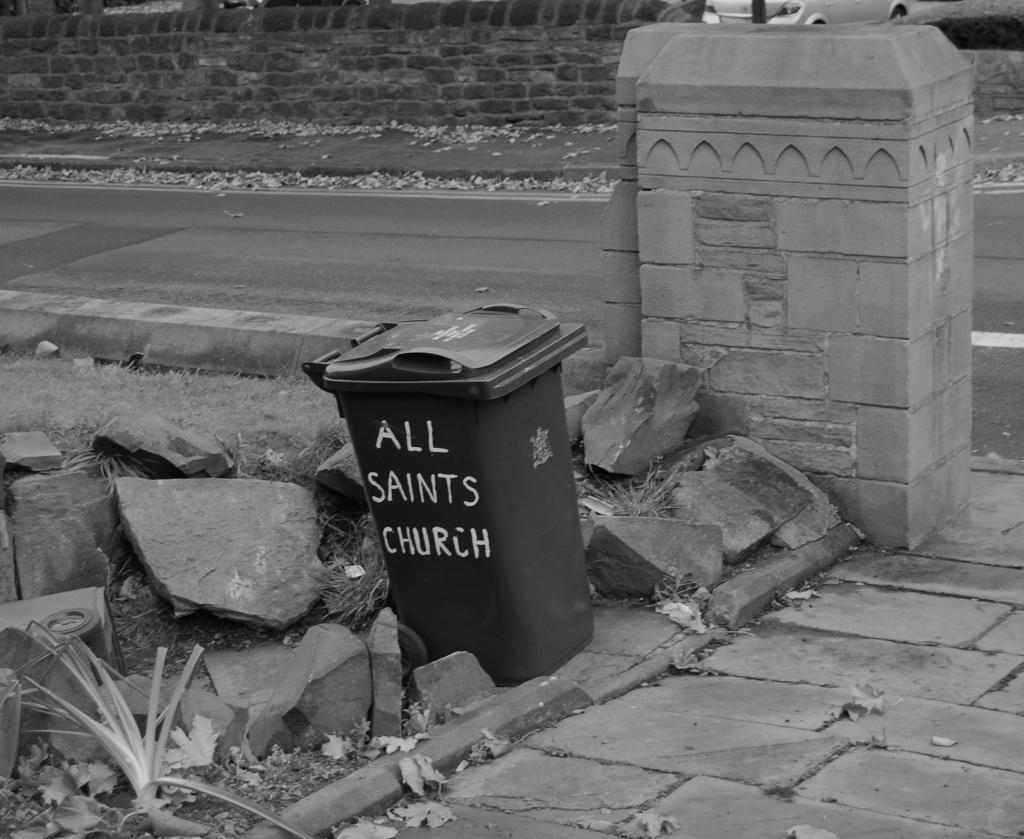<image>
Summarize the visual content of the image. A trash can contains white letters that spell out, "All Saints Church." 